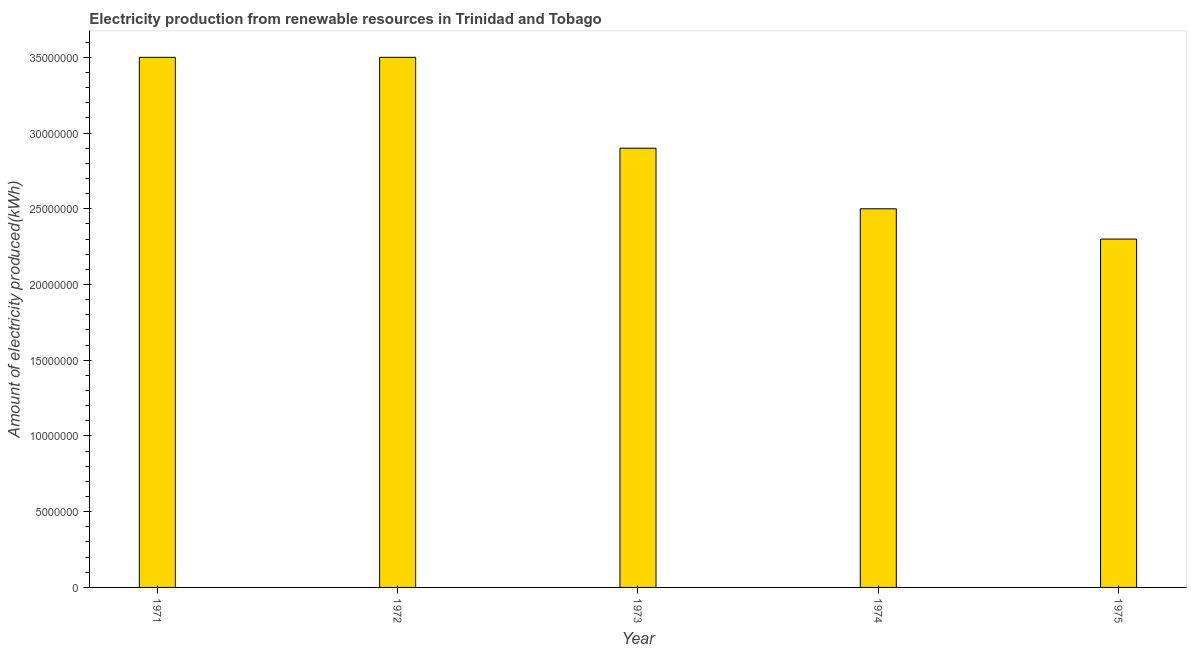What is the title of the graph?
Ensure brevity in your answer.  Electricity production from renewable resources in Trinidad and Tobago. What is the label or title of the X-axis?
Provide a short and direct response. Year. What is the label or title of the Y-axis?
Ensure brevity in your answer.  Amount of electricity produced(kWh). What is the amount of electricity produced in 1973?
Your response must be concise. 2.90e+07. Across all years, what is the maximum amount of electricity produced?
Give a very brief answer. 3.50e+07. Across all years, what is the minimum amount of electricity produced?
Your answer should be compact. 2.30e+07. In which year was the amount of electricity produced minimum?
Make the answer very short. 1975. What is the sum of the amount of electricity produced?
Offer a very short reply. 1.47e+08. What is the average amount of electricity produced per year?
Offer a very short reply. 2.94e+07. What is the median amount of electricity produced?
Offer a terse response. 2.90e+07. In how many years, is the amount of electricity produced greater than 1000000 kWh?
Make the answer very short. 5. Do a majority of the years between 1974 and 1971 (inclusive) have amount of electricity produced greater than 8000000 kWh?
Ensure brevity in your answer.  Yes. What is the ratio of the amount of electricity produced in 1974 to that in 1975?
Give a very brief answer. 1.09. Is the difference between the amount of electricity produced in 1974 and 1975 greater than the difference between any two years?
Make the answer very short. No. What is the difference between the highest and the second highest amount of electricity produced?
Give a very brief answer. 0. What is the difference between the highest and the lowest amount of electricity produced?
Make the answer very short. 1.20e+07. In how many years, is the amount of electricity produced greater than the average amount of electricity produced taken over all years?
Make the answer very short. 2. Are all the bars in the graph horizontal?
Your answer should be compact. No. What is the difference between two consecutive major ticks on the Y-axis?
Provide a short and direct response. 5.00e+06. What is the Amount of electricity produced(kWh) of 1971?
Offer a very short reply. 3.50e+07. What is the Amount of electricity produced(kWh) in 1972?
Make the answer very short. 3.50e+07. What is the Amount of electricity produced(kWh) in 1973?
Your answer should be compact. 2.90e+07. What is the Amount of electricity produced(kWh) of 1974?
Provide a short and direct response. 2.50e+07. What is the Amount of electricity produced(kWh) in 1975?
Your response must be concise. 2.30e+07. What is the difference between the Amount of electricity produced(kWh) in 1971 and 1973?
Your answer should be very brief. 6.00e+06. What is the difference between the Amount of electricity produced(kWh) in 1971 and 1975?
Offer a very short reply. 1.20e+07. What is the difference between the Amount of electricity produced(kWh) in 1972 and 1973?
Provide a short and direct response. 6.00e+06. What is the difference between the Amount of electricity produced(kWh) in 1972 and 1974?
Your response must be concise. 1.00e+07. What is the difference between the Amount of electricity produced(kWh) in 1973 and 1974?
Make the answer very short. 4.00e+06. What is the difference between the Amount of electricity produced(kWh) in 1974 and 1975?
Provide a short and direct response. 2.00e+06. What is the ratio of the Amount of electricity produced(kWh) in 1971 to that in 1973?
Your response must be concise. 1.21. What is the ratio of the Amount of electricity produced(kWh) in 1971 to that in 1974?
Make the answer very short. 1.4. What is the ratio of the Amount of electricity produced(kWh) in 1971 to that in 1975?
Give a very brief answer. 1.52. What is the ratio of the Amount of electricity produced(kWh) in 1972 to that in 1973?
Ensure brevity in your answer.  1.21. What is the ratio of the Amount of electricity produced(kWh) in 1972 to that in 1975?
Offer a terse response. 1.52. What is the ratio of the Amount of electricity produced(kWh) in 1973 to that in 1974?
Your answer should be compact. 1.16. What is the ratio of the Amount of electricity produced(kWh) in 1973 to that in 1975?
Offer a terse response. 1.26. What is the ratio of the Amount of electricity produced(kWh) in 1974 to that in 1975?
Provide a short and direct response. 1.09. 